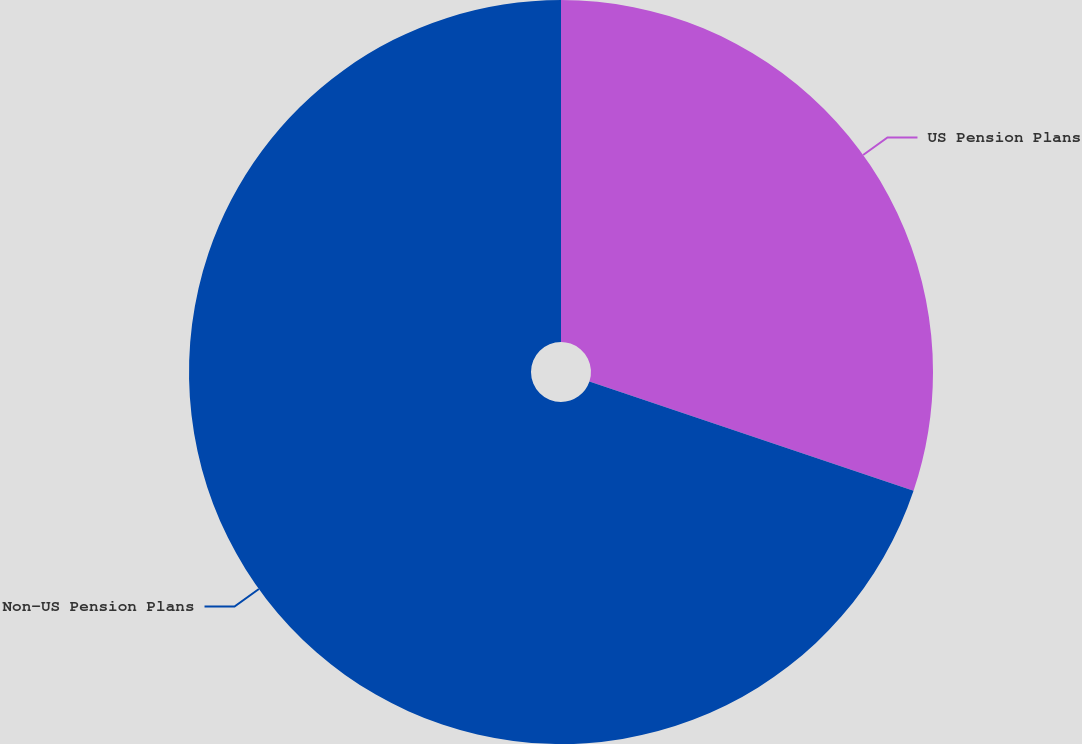<chart> <loc_0><loc_0><loc_500><loc_500><pie_chart><fcel>US Pension Plans<fcel>Non-US Pension Plans<nl><fcel>30.17%<fcel>69.83%<nl></chart> 